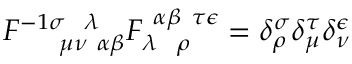<formula> <loc_0><loc_0><loc_500><loc_500>F _ { \mu \nu \alpha \beta } ^ { - 1 \sigma \lambda } F _ { \lambda \rho } ^ { \alpha \beta \tau \epsilon } = \delta _ { \rho } ^ { \sigma } \delta _ { \mu } ^ { \tau } \delta _ { \nu } ^ { \epsilon }</formula> 